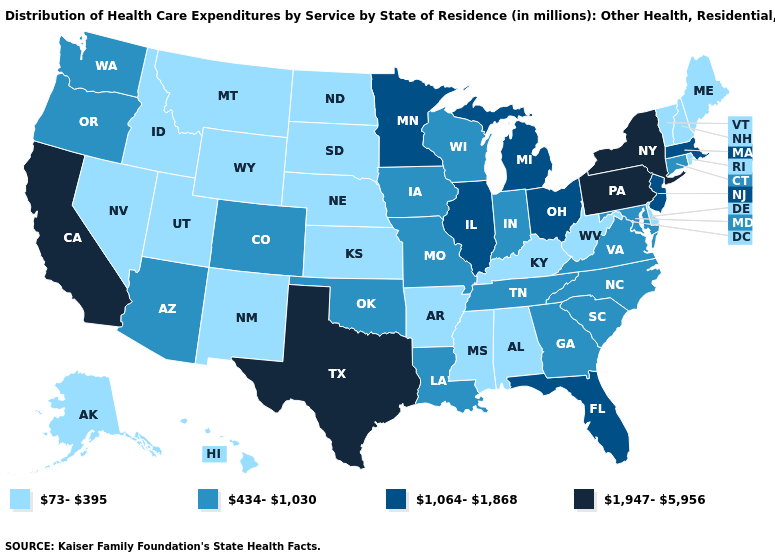Name the states that have a value in the range 434-1,030?
Short answer required. Arizona, Colorado, Connecticut, Georgia, Indiana, Iowa, Louisiana, Maryland, Missouri, North Carolina, Oklahoma, Oregon, South Carolina, Tennessee, Virginia, Washington, Wisconsin. Does the map have missing data?
Concise answer only. No. What is the value of Georgia?
Keep it brief. 434-1,030. What is the lowest value in states that border Alabama?
Quick response, please. 73-395. Which states hav the highest value in the MidWest?
Short answer required. Illinois, Michigan, Minnesota, Ohio. Does Hawaii have the lowest value in the West?
Quick response, please. Yes. Among the states that border Rhode Island , does Massachusetts have the highest value?
Short answer required. Yes. Name the states that have a value in the range 1,947-5,956?
Keep it brief. California, New York, Pennsylvania, Texas. Among the states that border Arkansas , which have the highest value?
Be succinct. Texas. What is the lowest value in states that border New Mexico?
Keep it brief. 73-395. Does Vermont have the highest value in the Northeast?
Be succinct. No. Does Massachusetts have the lowest value in the Northeast?
Write a very short answer. No. Which states have the lowest value in the West?
Answer briefly. Alaska, Hawaii, Idaho, Montana, Nevada, New Mexico, Utah, Wyoming. 